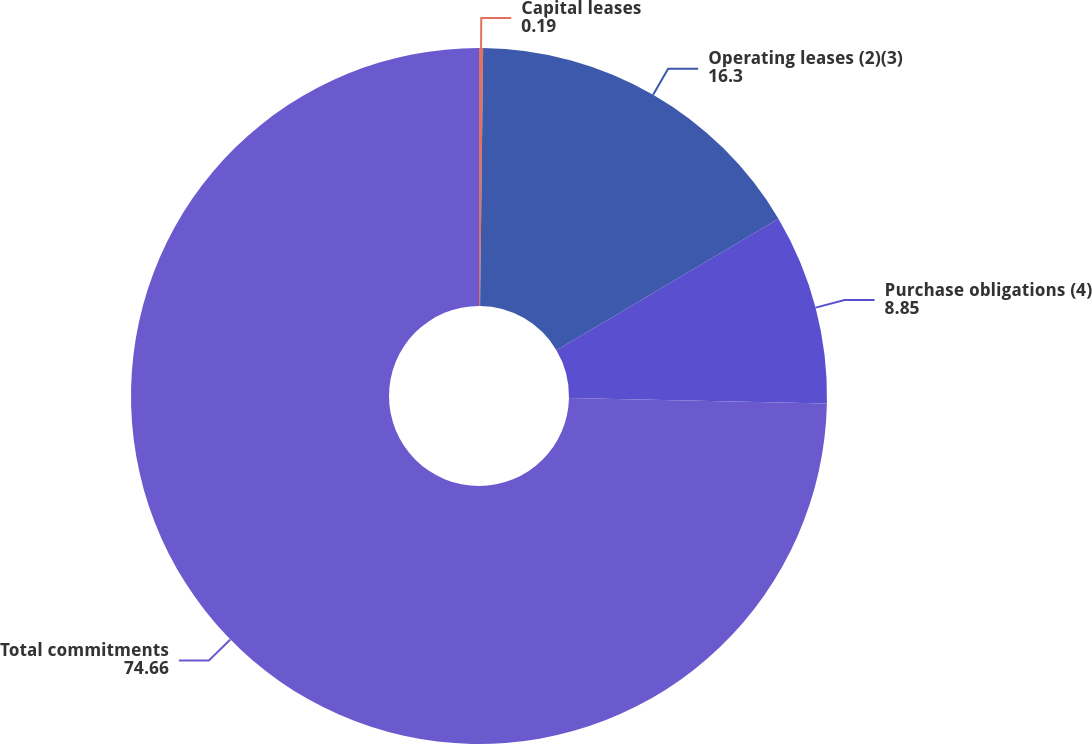Convert chart to OTSL. <chart><loc_0><loc_0><loc_500><loc_500><pie_chart><fcel>Capital leases<fcel>Operating leases (2)(3)<fcel>Purchase obligations (4)<fcel>Total commitments<nl><fcel>0.19%<fcel>16.3%<fcel>8.85%<fcel>74.66%<nl></chart> 